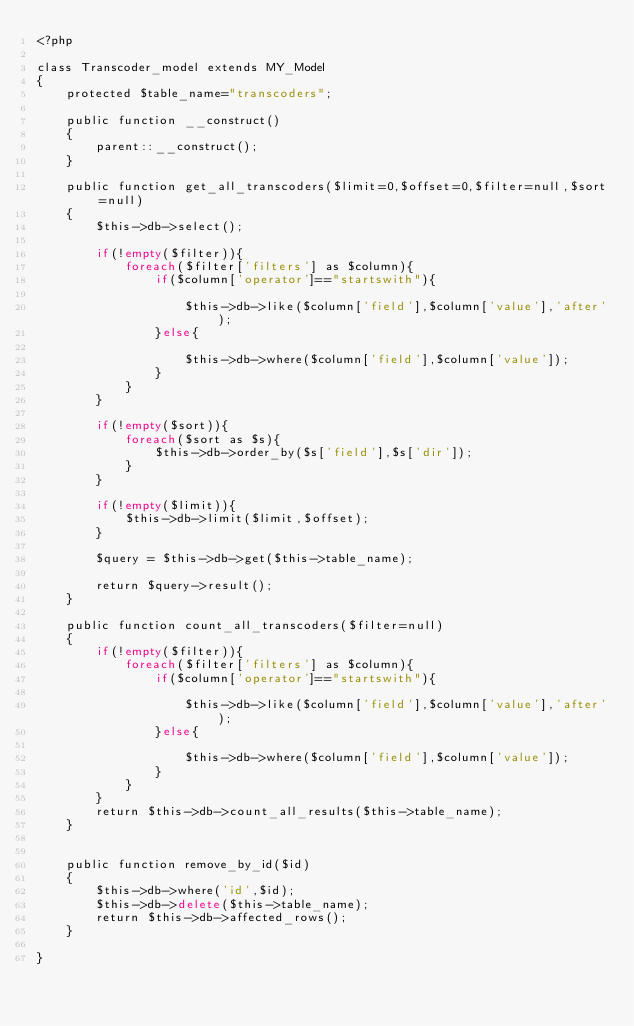Convert code to text. <code><loc_0><loc_0><loc_500><loc_500><_PHP_><?php

class Transcoder_model extends MY_Model
{
    protected $table_name="transcoders";

    public function __construct()
    {
        parent::__construct();
    }
    
    public function get_all_transcoders($limit=0,$offset=0,$filter=null,$sort=null)
    {
        $this->db->select();

        if(!empty($filter)){
            foreach($filter['filters'] as $column){
                if($column['operator']=="startswith"){

                    $this->db->like($column['field'],$column['value'],'after');
                }else{

                    $this->db->where($column['field'],$column['value']);
                }
            }
        }

        if(!empty($sort)){
            foreach($sort as $s){
                $this->db->order_by($s['field'],$s['dir']);
            }
        }

        if(!empty($limit)){
            $this->db->limit($limit,$offset);
        }

        $query = $this->db->get($this->table_name);

        return $query->result();
    }

    public function count_all_transcoders($filter=null)
    {
        if(!empty($filter)){
            foreach($filter['filters'] as $column){
                if($column['operator']=="startswith"){

                    $this->db->like($column['field'],$column['value'],'after');
                }else{

                    $this->db->where($column['field'],$column['value']);
                }
            }
        }
        return $this->db->count_all_results($this->table_name);
    }
    
    
    public function remove_by_id($id)
    {
        $this->db->where('id',$id);
        $this->db->delete($this->table_name);
        return $this->db->affected_rows();
    }

}

</code> 